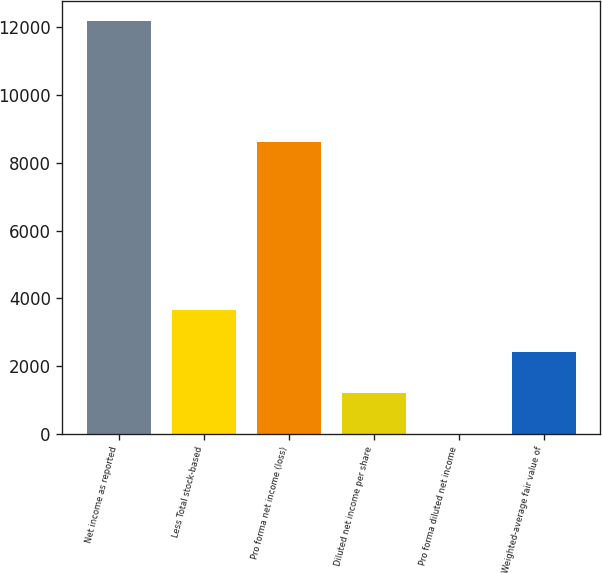<chart> <loc_0><loc_0><loc_500><loc_500><bar_chart><fcel>Net income as reported<fcel>Less Total stock-based<fcel>Pro forma net income (loss)<fcel>Diluted net income per share<fcel>Pro forma diluted net income<fcel>Weighted-average fair value of<nl><fcel>12164<fcel>3649.34<fcel>8601<fcel>1216.58<fcel>0.2<fcel>2432.96<nl></chart> 